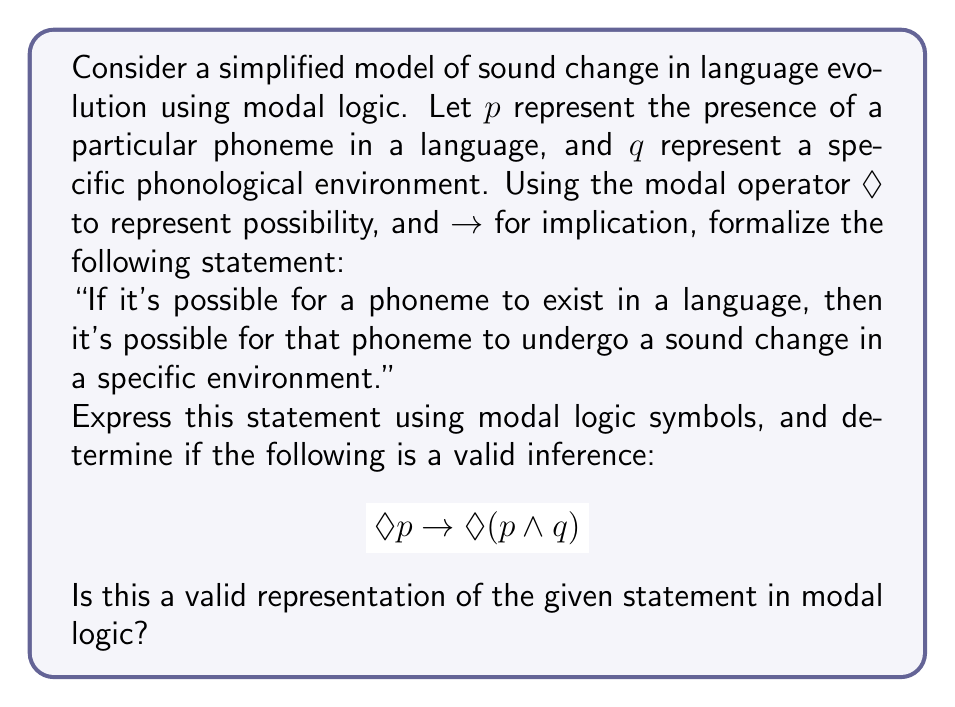Could you help me with this problem? To answer this question, we need to break down the statement and analyze its logical structure:

1. Let's first interpret the symbols:
   - $p$: presence of a particular phoneme
   - $q$: specific phonological environment
   - $\Diamond$: possibility operator
   - $\rightarrow$: implication
   - $\wedge$: conjunction (and)

2. The original statement has two parts:
   a) "If it's possible for a phoneme to exist in a language"
   b) "then it's possible for that phoneme to undergo a sound change in a specific environment"

3. Part (a) can be represented as $\Diamond p$

4. Part (b) is more complex. It suggests the possibility of both the phoneme existing and being in a specific environment. This can be represented as $\Diamond(p \wedge q)$

5. The implication between these two parts is represented by $\rightarrow$

6. Therefore, the complete logical representation is:
   $$\Diamond p \rightarrow \Diamond(p \wedge q)$$

7. Now, we need to determine if this is a valid representation:
   - The left side $\Diamond p$ correctly captures the possibility of a phoneme existing
   - The right side $\Diamond(p \wedge q)$ correctly captures the possibility of both the phoneme existing and being in a specific environment
   - The implication $\rightarrow$ correctly represents the "if...then" relationship

8. In the context of phonology and language evolution, this formula states that if it's possible for a phoneme to exist, then it's also possible for that phoneme to exist in a specific environment where it might undergo change.

9. This aligns with linguistic theories of sound change, where phonemes that exist in a language have the potential to undergo changes in specific phonological environments.

Therefore, this is indeed a valid representation of the given statement in modal logic.
Answer: Yes, $$\Diamond p \rightarrow \Diamond(p \wedge q)$$ is a valid representation of the given statement in modal logic. 